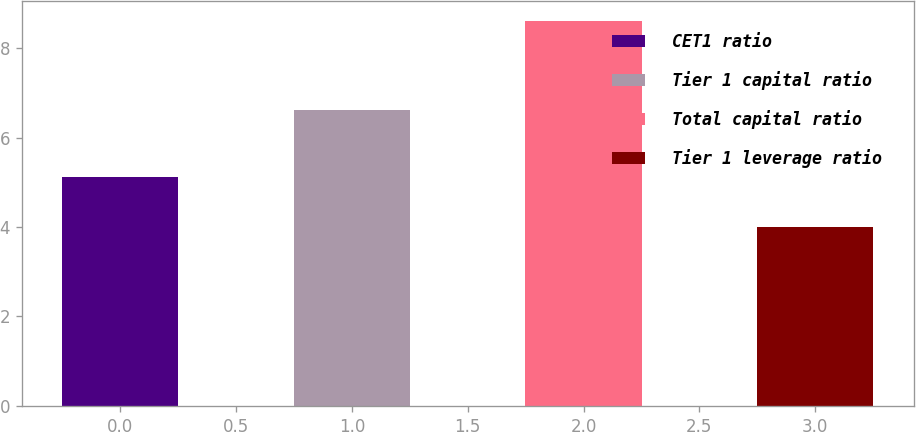<chart> <loc_0><loc_0><loc_500><loc_500><bar_chart><fcel>CET1 ratio<fcel>Tier 1 capital ratio<fcel>Total capital ratio<fcel>Tier 1 leverage ratio<nl><fcel>5.12<fcel>6.62<fcel>8.62<fcel>4<nl></chart> 